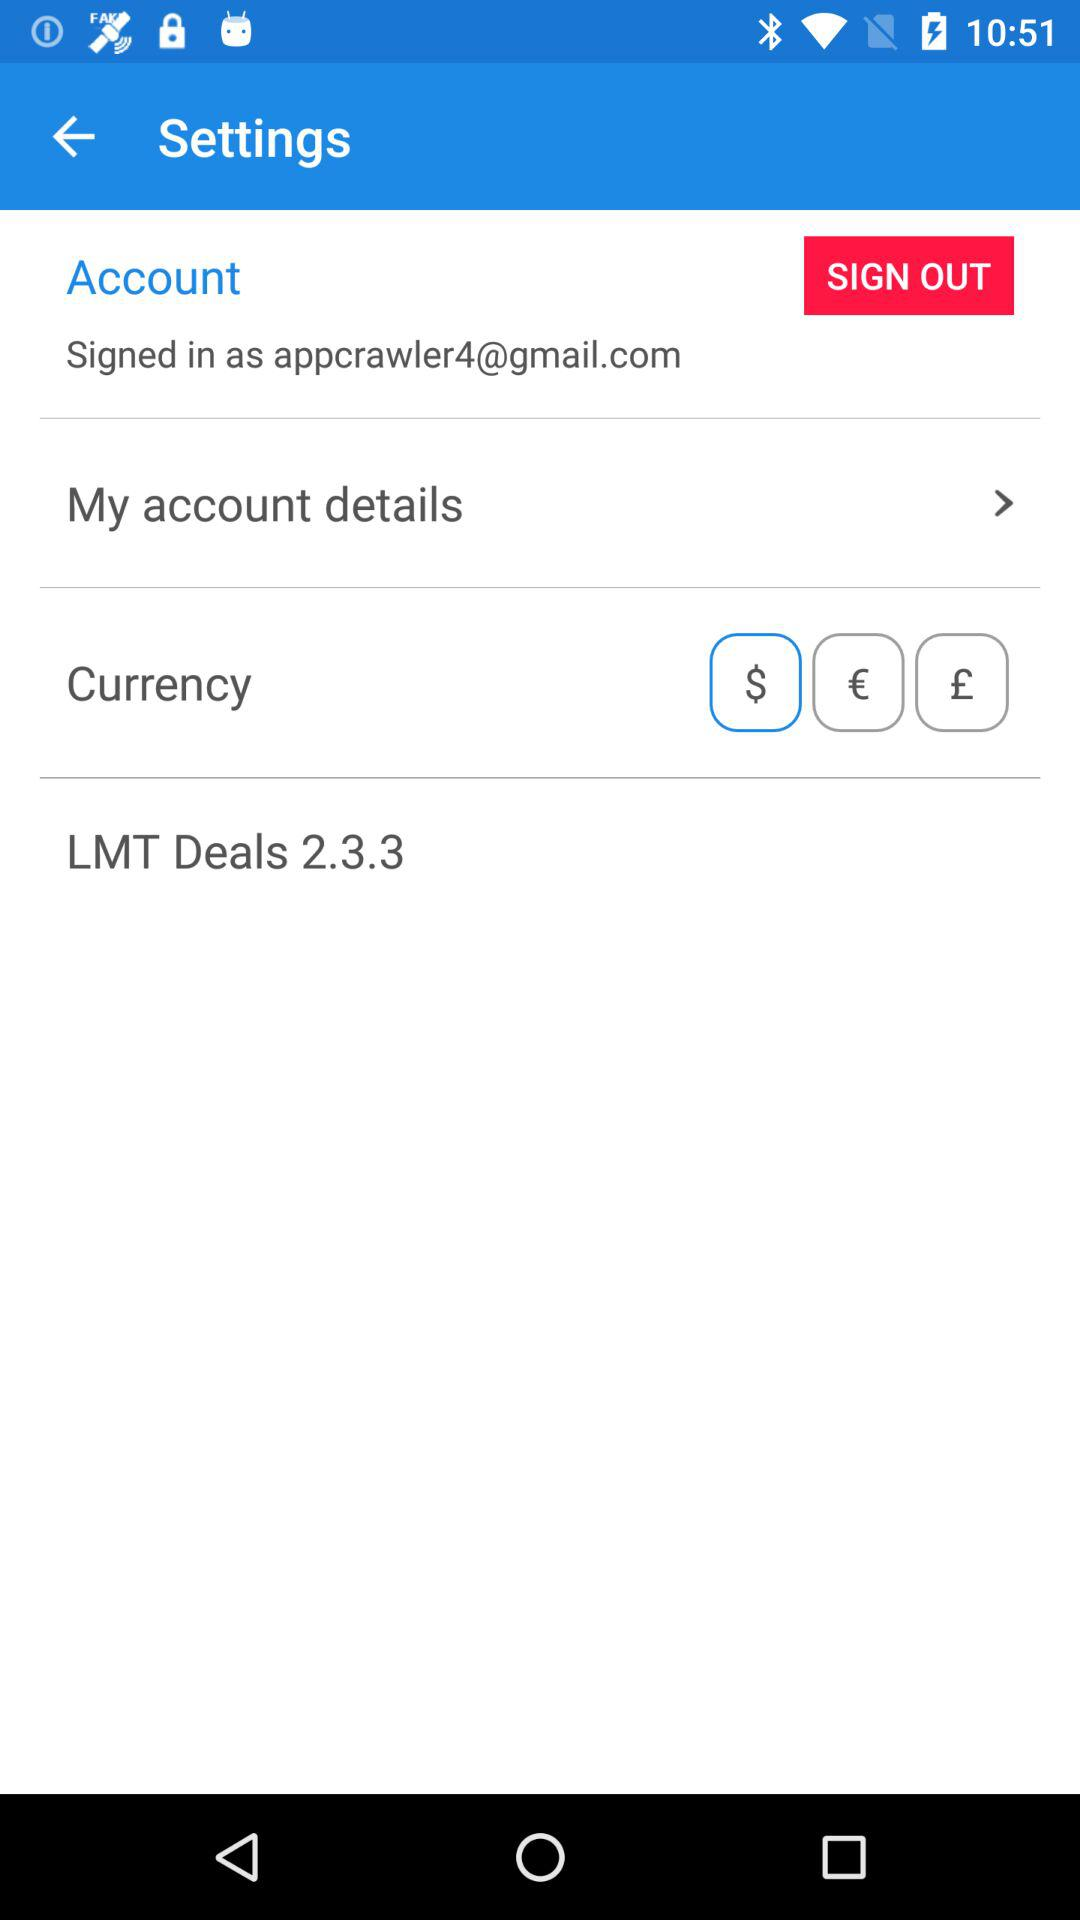What is the email address? The email address is appcrawler4@gmail.com. 